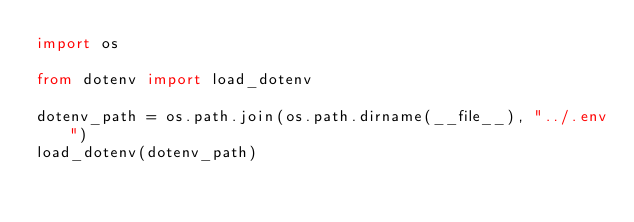Convert code to text. <code><loc_0><loc_0><loc_500><loc_500><_Python_>import os

from dotenv import load_dotenv

dotenv_path = os.path.join(os.path.dirname(__file__), "../.env")
load_dotenv(dotenv_path)
</code> 